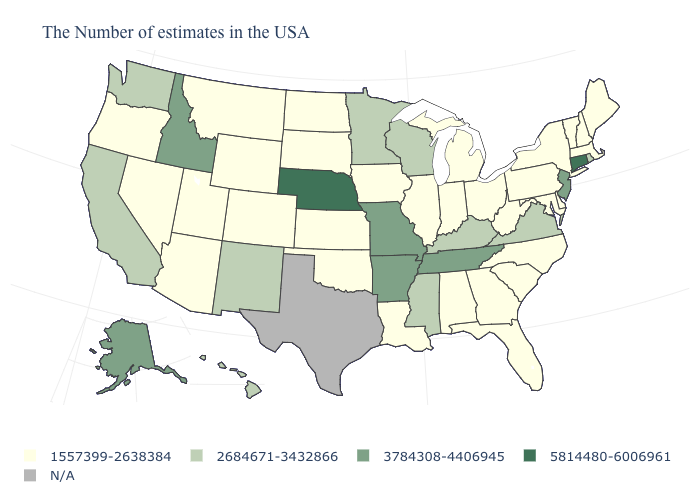Name the states that have a value in the range 2684671-3432866?
Write a very short answer. Rhode Island, Virginia, Kentucky, Wisconsin, Mississippi, Minnesota, New Mexico, California, Washington, Hawaii. What is the value of Hawaii?
Short answer required. 2684671-3432866. What is the value of West Virginia?
Answer briefly. 1557399-2638384. What is the value of Louisiana?
Keep it brief. 1557399-2638384. Does Rhode Island have the lowest value in the Northeast?
Answer briefly. No. Does New Mexico have the lowest value in the USA?
Keep it brief. No. What is the highest value in the West ?
Give a very brief answer. 3784308-4406945. What is the value of Indiana?
Short answer required. 1557399-2638384. Name the states that have a value in the range N/A?
Short answer required. Texas. Name the states that have a value in the range N/A?
Concise answer only. Texas. Is the legend a continuous bar?
Answer briefly. No. Name the states that have a value in the range 2684671-3432866?
Answer briefly. Rhode Island, Virginia, Kentucky, Wisconsin, Mississippi, Minnesota, New Mexico, California, Washington, Hawaii. Does Alaska have the highest value in the West?
Write a very short answer. Yes. 